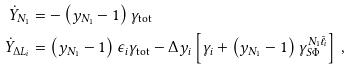<formula> <loc_0><loc_0><loc_500><loc_500>\dot { Y } _ { N _ { 1 } } & = - \left ( y _ { N _ { 1 } } - 1 \right ) \gamma _ { \text {tot} } \\ \dot { Y } _ { \Delta L _ { i } } & = \left ( y _ { N _ { 1 } } - 1 \right ) \epsilon _ { i } \gamma _ { \text {tot} } - \Delta y _ { i } \left [ \gamma _ { i } + \left ( y _ { N _ { 1 } } - 1 \right ) \gamma ^ { N _ { 1 } \bar { \ell } _ { i } } _ { S \Phi } \right ] \, ,</formula> 